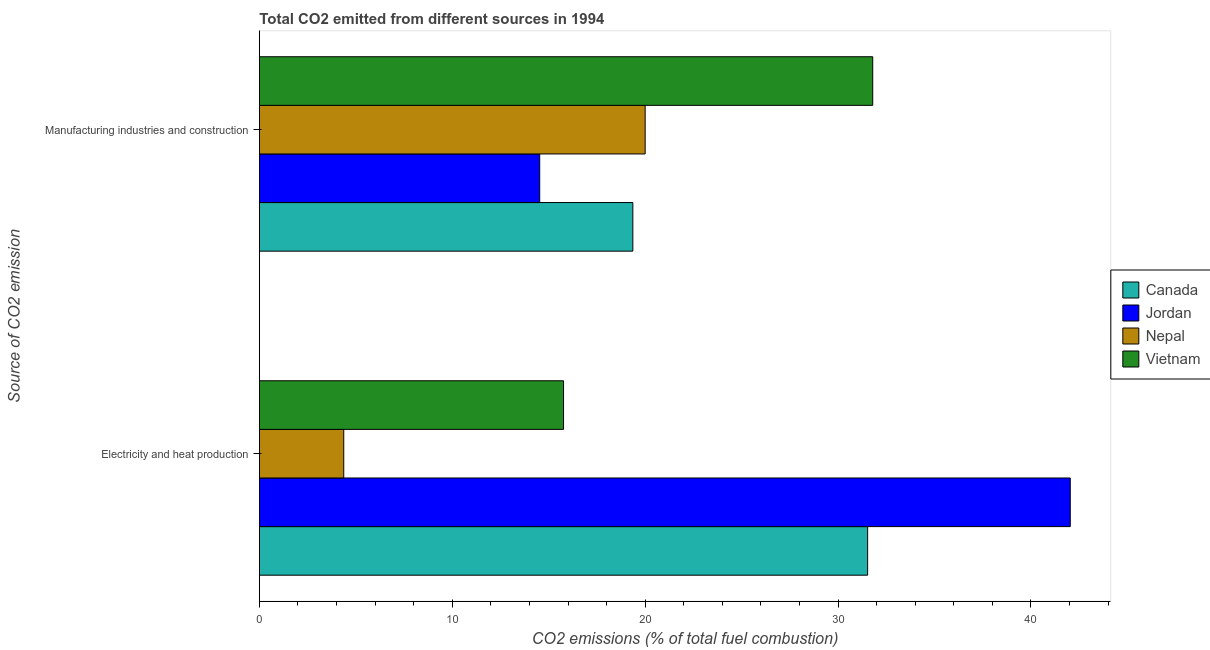How many different coloured bars are there?
Your answer should be very brief. 4. Are the number of bars per tick equal to the number of legend labels?
Provide a succinct answer. Yes. Are the number of bars on each tick of the Y-axis equal?
Your answer should be compact. Yes. How many bars are there on the 2nd tick from the top?
Make the answer very short. 4. How many bars are there on the 1st tick from the bottom?
Provide a short and direct response. 4. What is the label of the 2nd group of bars from the top?
Offer a terse response. Electricity and heat production. What is the co2 emissions due to electricity and heat production in Canada?
Make the answer very short. 31.53. Across all countries, what is the maximum co2 emissions due to electricity and heat production?
Offer a terse response. 42.04. Across all countries, what is the minimum co2 emissions due to manufacturing industries?
Your response must be concise. 14.53. In which country was the co2 emissions due to electricity and heat production maximum?
Offer a very short reply. Jordan. In which country was the co2 emissions due to manufacturing industries minimum?
Your answer should be compact. Jordan. What is the total co2 emissions due to electricity and heat production in the graph?
Give a very brief answer. 93.71. What is the difference between the co2 emissions due to manufacturing industries in Nepal and that in Vietnam?
Give a very brief answer. -11.8. What is the difference between the co2 emissions due to electricity and heat production in Nepal and the co2 emissions due to manufacturing industries in Canada?
Keep it short and to the point. -14.99. What is the average co2 emissions due to manufacturing industries per country?
Offer a terse response. 21.42. What is the difference between the co2 emissions due to manufacturing industries and co2 emissions due to electricity and heat production in Vietnam?
Keep it short and to the point. 16.03. What is the ratio of the co2 emissions due to manufacturing industries in Jordan to that in Vietnam?
Give a very brief answer. 0.46. What does the 2nd bar from the bottom in Manufacturing industries and construction represents?
Give a very brief answer. Jordan. What is the difference between two consecutive major ticks on the X-axis?
Offer a very short reply. 10. How are the legend labels stacked?
Your response must be concise. Vertical. What is the title of the graph?
Your answer should be compact. Total CO2 emitted from different sources in 1994. Does "Croatia" appear as one of the legend labels in the graph?
Provide a short and direct response. No. What is the label or title of the X-axis?
Provide a succinct answer. CO2 emissions (% of total fuel combustion). What is the label or title of the Y-axis?
Ensure brevity in your answer.  Source of CO2 emission. What is the CO2 emissions (% of total fuel combustion) in Canada in Electricity and heat production?
Offer a terse response. 31.53. What is the CO2 emissions (% of total fuel combustion) of Jordan in Electricity and heat production?
Offer a terse response. 42.04. What is the CO2 emissions (% of total fuel combustion) of Nepal in Electricity and heat production?
Keep it short and to the point. 4.38. What is the CO2 emissions (% of total fuel combustion) in Vietnam in Electricity and heat production?
Provide a succinct answer. 15.77. What is the CO2 emissions (% of total fuel combustion) of Canada in Manufacturing industries and construction?
Your response must be concise. 19.36. What is the CO2 emissions (% of total fuel combustion) in Jordan in Manufacturing industries and construction?
Offer a very short reply. 14.53. What is the CO2 emissions (% of total fuel combustion) of Nepal in Manufacturing industries and construction?
Offer a very short reply. 20. What is the CO2 emissions (% of total fuel combustion) in Vietnam in Manufacturing industries and construction?
Make the answer very short. 31.8. Across all Source of CO2 emission, what is the maximum CO2 emissions (% of total fuel combustion) in Canada?
Provide a short and direct response. 31.53. Across all Source of CO2 emission, what is the maximum CO2 emissions (% of total fuel combustion) in Jordan?
Offer a terse response. 42.04. Across all Source of CO2 emission, what is the maximum CO2 emissions (% of total fuel combustion) in Vietnam?
Your answer should be very brief. 31.8. Across all Source of CO2 emission, what is the minimum CO2 emissions (% of total fuel combustion) of Canada?
Offer a very short reply. 19.36. Across all Source of CO2 emission, what is the minimum CO2 emissions (% of total fuel combustion) of Jordan?
Ensure brevity in your answer.  14.53. Across all Source of CO2 emission, what is the minimum CO2 emissions (% of total fuel combustion) of Nepal?
Your response must be concise. 4.38. Across all Source of CO2 emission, what is the minimum CO2 emissions (% of total fuel combustion) in Vietnam?
Keep it short and to the point. 15.77. What is the total CO2 emissions (% of total fuel combustion) of Canada in the graph?
Your response must be concise. 50.89. What is the total CO2 emissions (% of total fuel combustion) of Jordan in the graph?
Provide a short and direct response. 56.57. What is the total CO2 emissions (% of total fuel combustion) in Nepal in the graph?
Provide a short and direct response. 24.38. What is the total CO2 emissions (% of total fuel combustion) of Vietnam in the graph?
Make the answer very short. 47.57. What is the difference between the CO2 emissions (% of total fuel combustion) in Canada in Electricity and heat production and that in Manufacturing industries and construction?
Make the answer very short. 12.17. What is the difference between the CO2 emissions (% of total fuel combustion) in Jordan in Electricity and heat production and that in Manufacturing industries and construction?
Provide a short and direct response. 27.5. What is the difference between the CO2 emissions (% of total fuel combustion) in Nepal in Electricity and heat production and that in Manufacturing industries and construction?
Make the answer very short. -15.62. What is the difference between the CO2 emissions (% of total fuel combustion) of Vietnam in Electricity and heat production and that in Manufacturing industries and construction?
Your answer should be compact. -16.03. What is the difference between the CO2 emissions (% of total fuel combustion) of Canada in Electricity and heat production and the CO2 emissions (% of total fuel combustion) of Jordan in Manufacturing industries and construction?
Offer a very short reply. 17. What is the difference between the CO2 emissions (% of total fuel combustion) of Canada in Electricity and heat production and the CO2 emissions (% of total fuel combustion) of Nepal in Manufacturing industries and construction?
Offer a terse response. 11.53. What is the difference between the CO2 emissions (% of total fuel combustion) of Canada in Electricity and heat production and the CO2 emissions (% of total fuel combustion) of Vietnam in Manufacturing industries and construction?
Ensure brevity in your answer.  -0.26. What is the difference between the CO2 emissions (% of total fuel combustion) of Jordan in Electricity and heat production and the CO2 emissions (% of total fuel combustion) of Nepal in Manufacturing industries and construction?
Your response must be concise. 22.04. What is the difference between the CO2 emissions (% of total fuel combustion) in Jordan in Electricity and heat production and the CO2 emissions (% of total fuel combustion) in Vietnam in Manufacturing industries and construction?
Provide a short and direct response. 10.24. What is the difference between the CO2 emissions (% of total fuel combustion) of Nepal in Electricity and heat production and the CO2 emissions (% of total fuel combustion) of Vietnam in Manufacturing industries and construction?
Your answer should be very brief. -27.42. What is the average CO2 emissions (% of total fuel combustion) in Canada per Source of CO2 emission?
Your response must be concise. 25.45. What is the average CO2 emissions (% of total fuel combustion) of Jordan per Source of CO2 emission?
Offer a terse response. 28.29. What is the average CO2 emissions (% of total fuel combustion) of Nepal per Source of CO2 emission?
Ensure brevity in your answer.  12.19. What is the average CO2 emissions (% of total fuel combustion) in Vietnam per Source of CO2 emission?
Provide a succinct answer. 23.78. What is the difference between the CO2 emissions (% of total fuel combustion) of Canada and CO2 emissions (% of total fuel combustion) of Jordan in Electricity and heat production?
Provide a short and direct response. -10.5. What is the difference between the CO2 emissions (% of total fuel combustion) in Canada and CO2 emissions (% of total fuel combustion) in Nepal in Electricity and heat production?
Offer a terse response. 27.16. What is the difference between the CO2 emissions (% of total fuel combustion) in Canada and CO2 emissions (% of total fuel combustion) in Vietnam in Electricity and heat production?
Offer a terse response. 15.76. What is the difference between the CO2 emissions (% of total fuel combustion) in Jordan and CO2 emissions (% of total fuel combustion) in Nepal in Electricity and heat production?
Your response must be concise. 37.66. What is the difference between the CO2 emissions (% of total fuel combustion) in Jordan and CO2 emissions (% of total fuel combustion) in Vietnam in Electricity and heat production?
Offer a very short reply. 26.27. What is the difference between the CO2 emissions (% of total fuel combustion) of Nepal and CO2 emissions (% of total fuel combustion) of Vietnam in Electricity and heat production?
Your response must be concise. -11.39. What is the difference between the CO2 emissions (% of total fuel combustion) of Canada and CO2 emissions (% of total fuel combustion) of Jordan in Manufacturing industries and construction?
Your answer should be very brief. 4.83. What is the difference between the CO2 emissions (% of total fuel combustion) of Canada and CO2 emissions (% of total fuel combustion) of Nepal in Manufacturing industries and construction?
Ensure brevity in your answer.  -0.64. What is the difference between the CO2 emissions (% of total fuel combustion) of Canada and CO2 emissions (% of total fuel combustion) of Vietnam in Manufacturing industries and construction?
Ensure brevity in your answer.  -12.44. What is the difference between the CO2 emissions (% of total fuel combustion) of Jordan and CO2 emissions (% of total fuel combustion) of Nepal in Manufacturing industries and construction?
Keep it short and to the point. -5.47. What is the difference between the CO2 emissions (% of total fuel combustion) of Jordan and CO2 emissions (% of total fuel combustion) of Vietnam in Manufacturing industries and construction?
Your answer should be compact. -17.26. What is the difference between the CO2 emissions (% of total fuel combustion) in Nepal and CO2 emissions (% of total fuel combustion) in Vietnam in Manufacturing industries and construction?
Provide a succinct answer. -11.8. What is the ratio of the CO2 emissions (% of total fuel combustion) in Canada in Electricity and heat production to that in Manufacturing industries and construction?
Keep it short and to the point. 1.63. What is the ratio of the CO2 emissions (% of total fuel combustion) of Jordan in Electricity and heat production to that in Manufacturing industries and construction?
Your answer should be very brief. 2.89. What is the ratio of the CO2 emissions (% of total fuel combustion) of Nepal in Electricity and heat production to that in Manufacturing industries and construction?
Give a very brief answer. 0.22. What is the ratio of the CO2 emissions (% of total fuel combustion) in Vietnam in Electricity and heat production to that in Manufacturing industries and construction?
Your response must be concise. 0.5. What is the difference between the highest and the second highest CO2 emissions (% of total fuel combustion) of Canada?
Provide a short and direct response. 12.17. What is the difference between the highest and the second highest CO2 emissions (% of total fuel combustion) in Jordan?
Give a very brief answer. 27.5. What is the difference between the highest and the second highest CO2 emissions (% of total fuel combustion) in Nepal?
Offer a terse response. 15.62. What is the difference between the highest and the second highest CO2 emissions (% of total fuel combustion) in Vietnam?
Ensure brevity in your answer.  16.03. What is the difference between the highest and the lowest CO2 emissions (% of total fuel combustion) in Canada?
Give a very brief answer. 12.17. What is the difference between the highest and the lowest CO2 emissions (% of total fuel combustion) of Jordan?
Keep it short and to the point. 27.5. What is the difference between the highest and the lowest CO2 emissions (% of total fuel combustion) of Nepal?
Provide a short and direct response. 15.62. What is the difference between the highest and the lowest CO2 emissions (% of total fuel combustion) of Vietnam?
Provide a succinct answer. 16.03. 